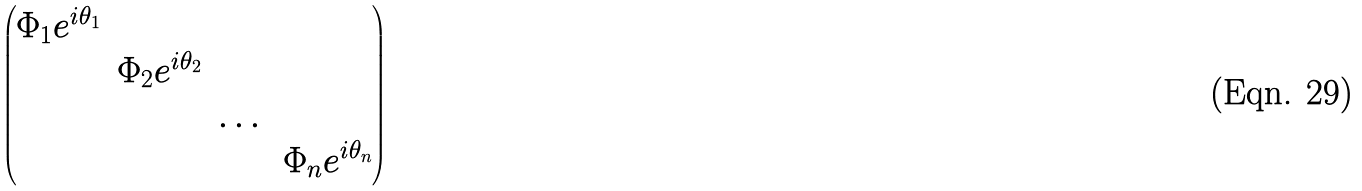Convert formula to latex. <formula><loc_0><loc_0><loc_500><loc_500>\begin{pmatrix} \Phi _ { 1 } e ^ { i \theta _ { 1 } } & & & \\ & \Phi _ { 2 } e ^ { i \theta _ { 2 } } & & \\ & & \dots & \\ & & & \Phi _ { n } e ^ { i \theta _ { n } } \end{pmatrix}</formula> 